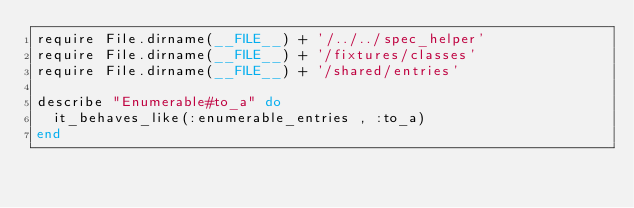<code> <loc_0><loc_0><loc_500><loc_500><_Ruby_>require File.dirname(__FILE__) + '/../../spec_helper'
require File.dirname(__FILE__) + '/fixtures/classes'
require File.dirname(__FILE__) + '/shared/entries'

describe "Enumerable#to_a" do   
  it_behaves_like(:enumerable_entries , :to_a) 
end
</code> 